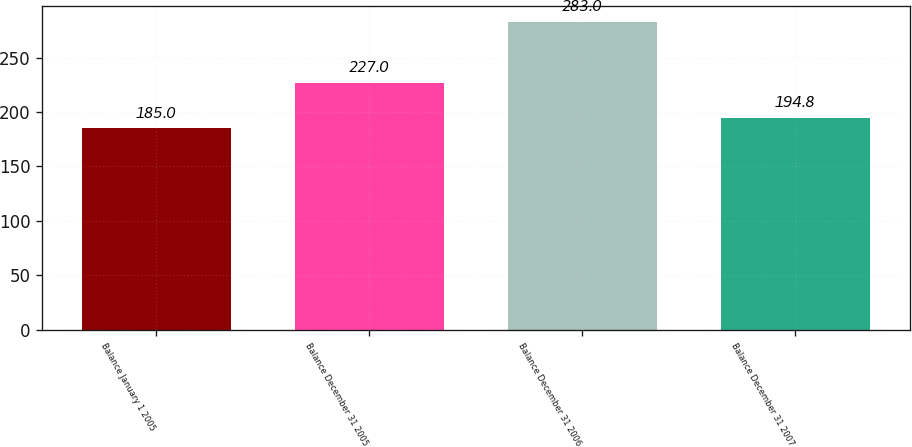<chart> <loc_0><loc_0><loc_500><loc_500><bar_chart><fcel>Balance January 1 2005<fcel>Balance December 31 2005<fcel>Balance December 31 2006<fcel>Balance December 31 2007<nl><fcel>185<fcel>227<fcel>283<fcel>194.8<nl></chart> 